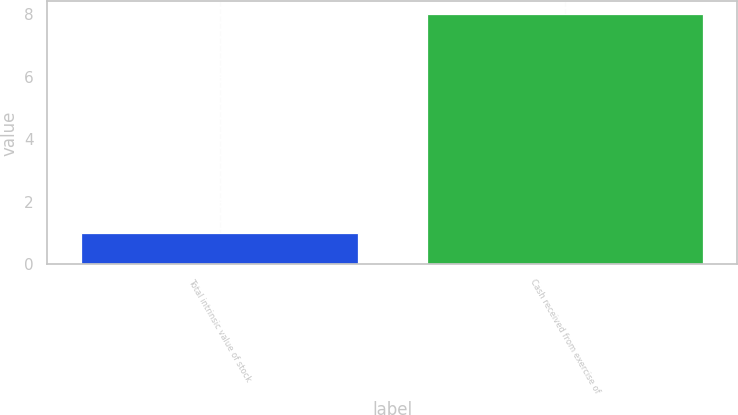Convert chart. <chart><loc_0><loc_0><loc_500><loc_500><bar_chart><fcel>Total intrinsic value of stock<fcel>Cash received from exercise of<nl><fcel>1<fcel>8<nl></chart> 